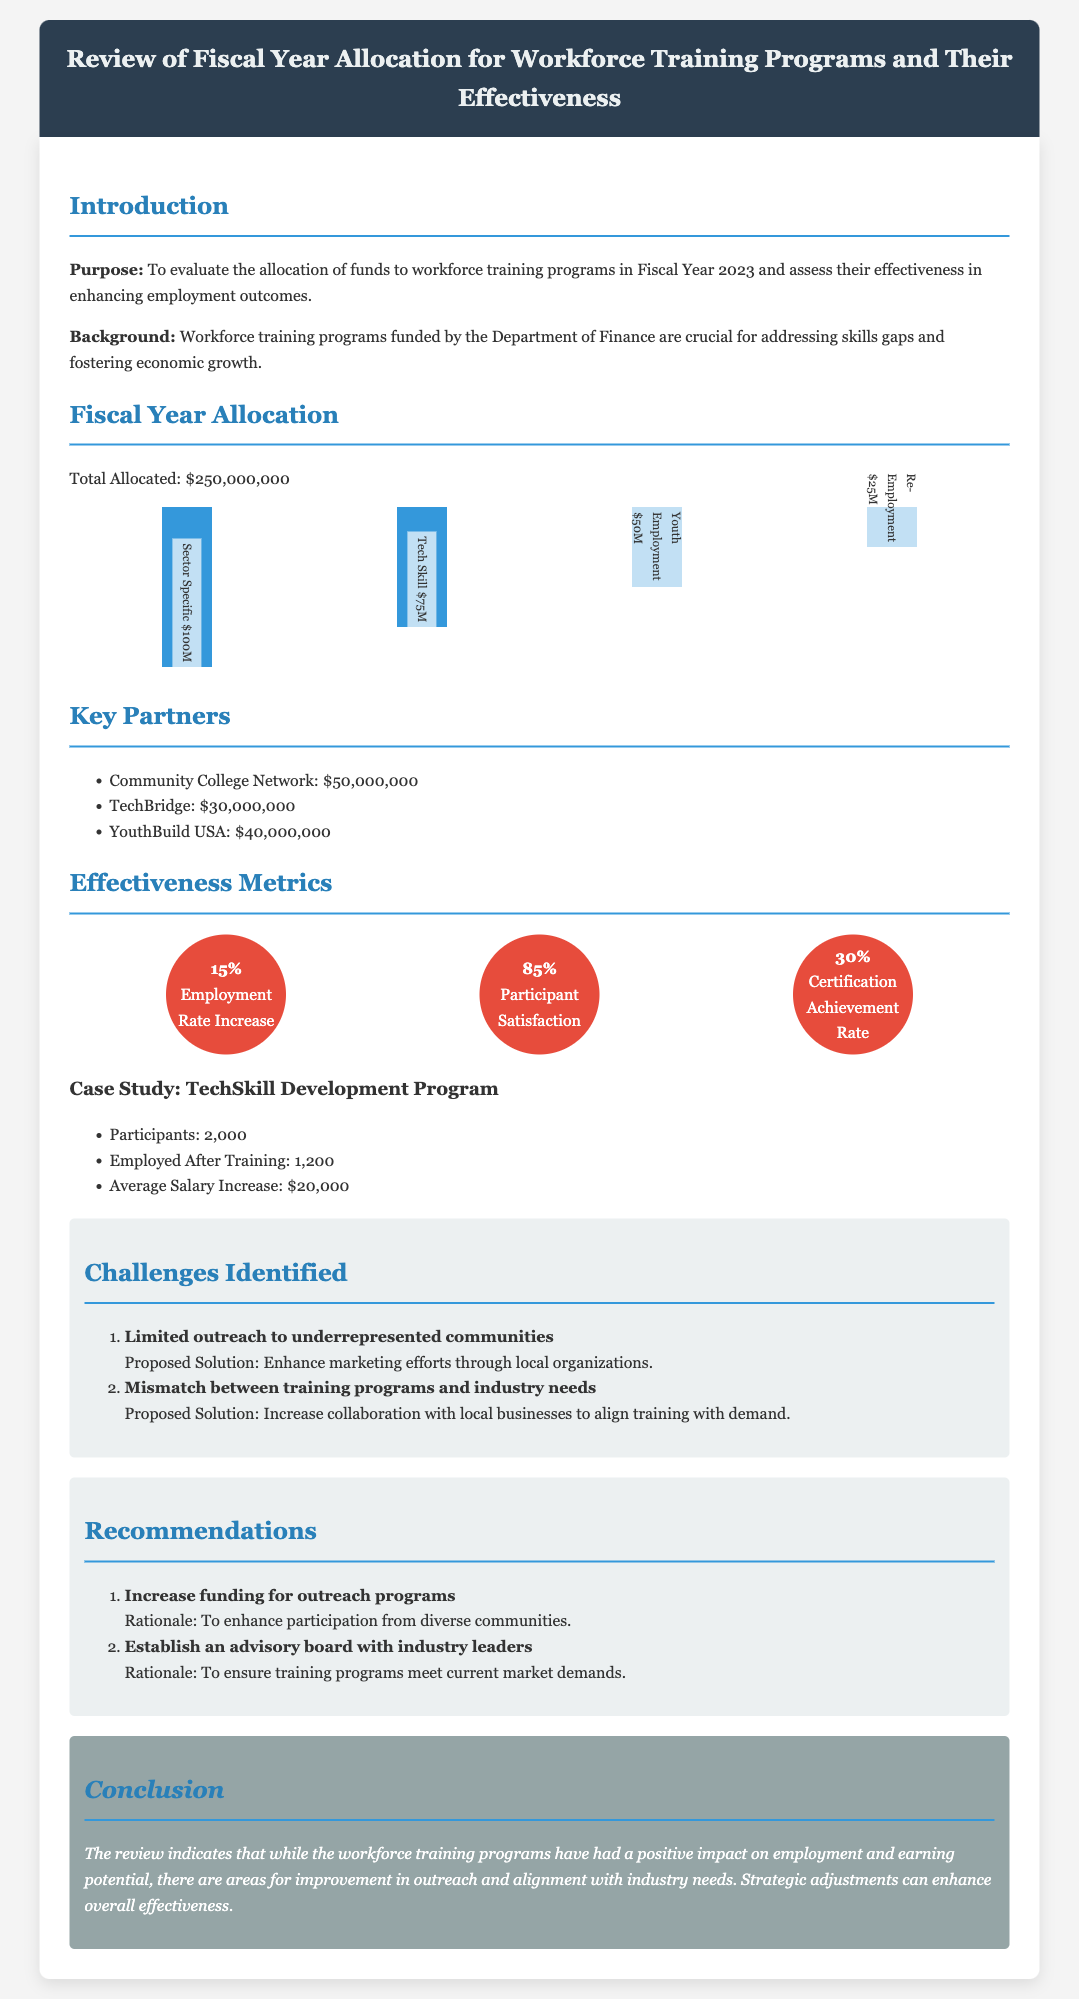What is the total allocated amount for workforce training programs? The total allocated amount is stated in the document as $250,000,000.
Answer: $250,000,000 What is the employment rate increase percentage? The document specifies a 15% increase in the employment rate as a result of the training programs.
Answer: 15% Who is a key partner receiving funding? The document lists several key partners, including the Community College Network, which receives $50,000,000.
Answer: Community College Network What challenge is identified regarding outreach? The document highlights "Limited outreach to underrepresented communities" as a key challenge.
Answer: Limited outreach to underrepresented communities What is the average salary increase reported in the case study? The case study mentions an average salary increase of $20,000 for participants completing the training program.
Answer: $20,000 What recommendation suggests increasing funding? The document recommends to "Increase funding for outreach programs" to enhance participation.
Answer: Increase funding for outreach programs What is the certification achievement rate? The document states that the certification achievement rate is 30%.
Answer: 30% How many participants were in the TechSkill Development Program? The TechSkill Development Program had a total of 2,000 participants as noted in the case study.
Answer: 2,000 